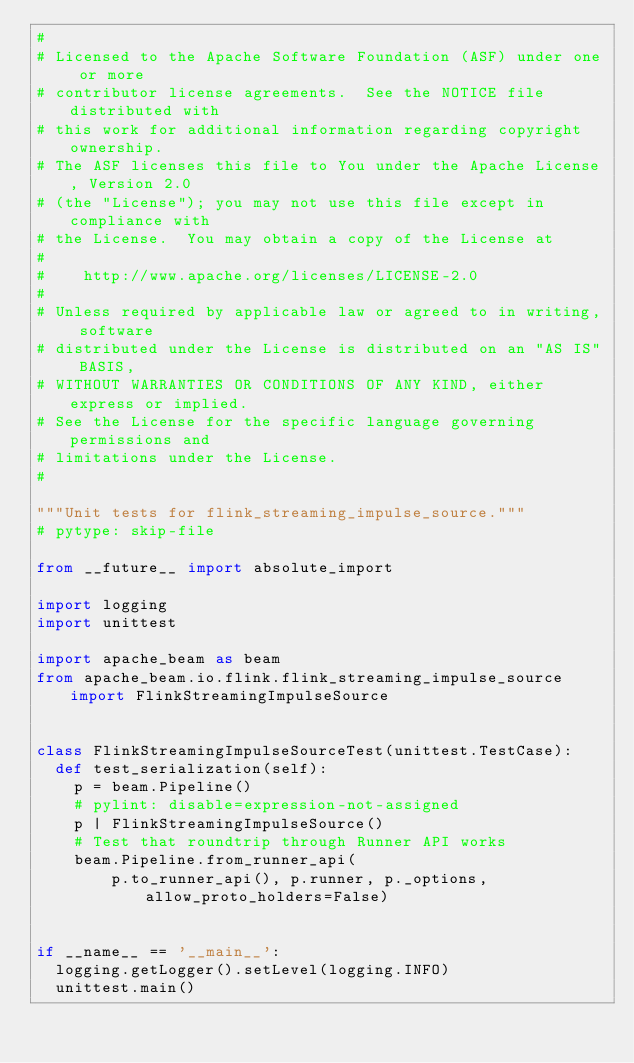Convert code to text. <code><loc_0><loc_0><loc_500><loc_500><_Python_>#
# Licensed to the Apache Software Foundation (ASF) under one or more
# contributor license agreements.  See the NOTICE file distributed with
# this work for additional information regarding copyright ownership.
# The ASF licenses this file to You under the Apache License, Version 2.0
# (the "License"); you may not use this file except in compliance with
# the License.  You may obtain a copy of the License at
#
#    http://www.apache.org/licenses/LICENSE-2.0
#
# Unless required by applicable law or agreed to in writing, software
# distributed under the License is distributed on an "AS IS" BASIS,
# WITHOUT WARRANTIES OR CONDITIONS OF ANY KIND, either express or implied.
# See the License for the specific language governing permissions and
# limitations under the License.
#

"""Unit tests for flink_streaming_impulse_source."""
# pytype: skip-file

from __future__ import absolute_import

import logging
import unittest

import apache_beam as beam
from apache_beam.io.flink.flink_streaming_impulse_source import FlinkStreamingImpulseSource


class FlinkStreamingImpulseSourceTest(unittest.TestCase):
  def test_serialization(self):
    p = beam.Pipeline()
    # pylint: disable=expression-not-assigned
    p | FlinkStreamingImpulseSource()
    # Test that roundtrip through Runner API works
    beam.Pipeline.from_runner_api(
        p.to_runner_api(), p.runner, p._options, allow_proto_holders=False)


if __name__ == '__main__':
  logging.getLogger().setLevel(logging.INFO)
  unittest.main()
</code> 